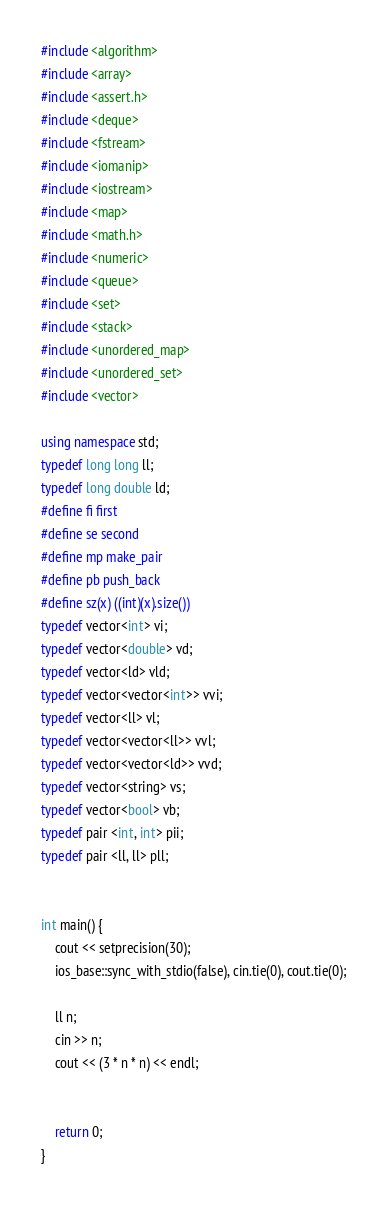Convert code to text. <code><loc_0><loc_0><loc_500><loc_500><_C++_>#include <algorithm>
#include <array>
#include <assert.h>
#include <deque>
#include <fstream>
#include <iomanip>
#include <iostream>
#include <map>
#include <math.h>
#include <numeric>
#include <queue>
#include <set>
#include <stack>
#include <unordered_map>
#include <unordered_set>
#include <vector>

using namespace std;
typedef long long ll;
typedef long double ld;
#define fi first
#define se second
#define mp make_pair
#define pb push_back
#define sz(x) ((int)(x).size())
typedef vector<int> vi;
typedef vector<double> vd;
typedef vector<ld> vld;
typedef vector<vector<int>> vvi;
typedef vector<ll> vl;
typedef vector<vector<ll>> vvl;
typedef vector<vector<ld>> vvd;
typedef vector<string> vs;
typedef vector<bool> vb;
typedef pair <int, int> pii;
typedef pair <ll, ll> pll;


int main() {
    cout << setprecision(30);
    ios_base::sync_with_stdio(false), cin.tie(0), cout.tie(0);

    ll n;
    cin >> n;
    cout << (3 * n * n) << endl;


    return 0;
}
</code> 